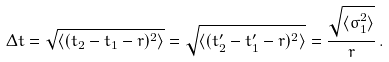Convert formula to latex. <formula><loc_0><loc_0><loc_500><loc_500>\Delta t = \sqrt { \langle ( t _ { 2 } - t _ { 1 } - r ) ^ { 2 } \rangle } = \sqrt { \langle ( t ^ { \prime } _ { 2 } - t ^ { \prime } _ { 1 } - r ) ^ { 2 } \rangle } = \frac { \sqrt { \langle \sigma _ { 1 } ^ { 2 } \rangle } } { r } \, .</formula> 